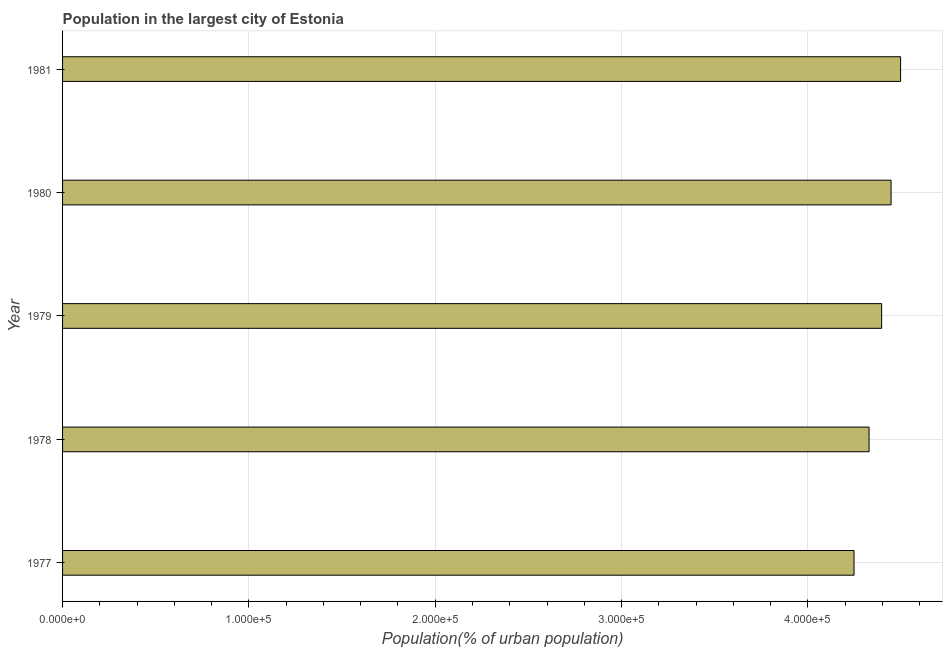What is the title of the graph?
Offer a terse response. Population in the largest city of Estonia. What is the label or title of the X-axis?
Ensure brevity in your answer.  Population(% of urban population). What is the population in largest city in 1980?
Make the answer very short. 4.45e+05. Across all years, what is the maximum population in largest city?
Your response must be concise. 4.50e+05. Across all years, what is the minimum population in largest city?
Your answer should be very brief. 4.25e+05. In which year was the population in largest city maximum?
Ensure brevity in your answer.  1981. What is the sum of the population in largest city?
Give a very brief answer. 2.19e+06. What is the difference between the population in largest city in 1977 and 1978?
Make the answer very short. -8064. What is the average population in largest city per year?
Offer a very short reply. 4.38e+05. What is the median population in largest city?
Give a very brief answer. 4.40e+05. In how many years, is the population in largest city greater than 60000 %?
Offer a very short reply. 5. What is the ratio of the population in largest city in 1980 to that in 1981?
Make the answer very short. 0.99. What is the difference between the highest and the second highest population in largest city?
Ensure brevity in your answer.  5105. Is the sum of the population in largest city in 1979 and 1980 greater than the maximum population in largest city across all years?
Provide a succinct answer. Yes. What is the difference between the highest and the lowest population in largest city?
Your answer should be very brief. 2.50e+04. In how many years, is the population in largest city greater than the average population in largest city taken over all years?
Ensure brevity in your answer.  3. How many bars are there?
Ensure brevity in your answer.  5. What is the Population(% of urban population) in 1977?
Provide a succinct answer. 4.25e+05. What is the Population(% of urban population) of 1978?
Provide a succinct answer. 4.33e+05. What is the Population(% of urban population) of 1979?
Your response must be concise. 4.40e+05. What is the Population(% of urban population) in 1980?
Your response must be concise. 4.45e+05. What is the Population(% of urban population) of 1981?
Your answer should be very brief. 4.50e+05. What is the difference between the Population(% of urban population) in 1977 and 1978?
Make the answer very short. -8064. What is the difference between the Population(% of urban population) in 1977 and 1979?
Make the answer very short. -1.48e+04. What is the difference between the Population(% of urban population) in 1977 and 1980?
Your answer should be very brief. -1.99e+04. What is the difference between the Population(% of urban population) in 1977 and 1981?
Keep it short and to the point. -2.50e+04. What is the difference between the Population(% of urban population) in 1978 and 1979?
Offer a terse response. -6750. What is the difference between the Population(% of urban population) in 1978 and 1980?
Offer a very short reply. -1.18e+04. What is the difference between the Population(% of urban population) in 1978 and 1981?
Your answer should be very brief. -1.69e+04. What is the difference between the Population(% of urban population) in 1979 and 1980?
Provide a succinct answer. -5060. What is the difference between the Population(% of urban population) in 1979 and 1981?
Offer a very short reply. -1.02e+04. What is the difference between the Population(% of urban population) in 1980 and 1981?
Ensure brevity in your answer.  -5105. What is the ratio of the Population(% of urban population) in 1977 to that in 1980?
Give a very brief answer. 0.95. What is the ratio of the Population(% of urban population) in 1977 to that in 1981?
Make the answer very short. 0.94. What is the ratio of the Population(% of urban population) in 1978 to that in 1980?
Offer a very short reply. 0.97. What is the ratio of the Population(% of urban population) in 1978 to that in 1981?
Your answer should be compact. 0.96. What is the ratio of the Population(% of urban population) in 1979 to that in 1981?
Offer a terse response. 0.98. 